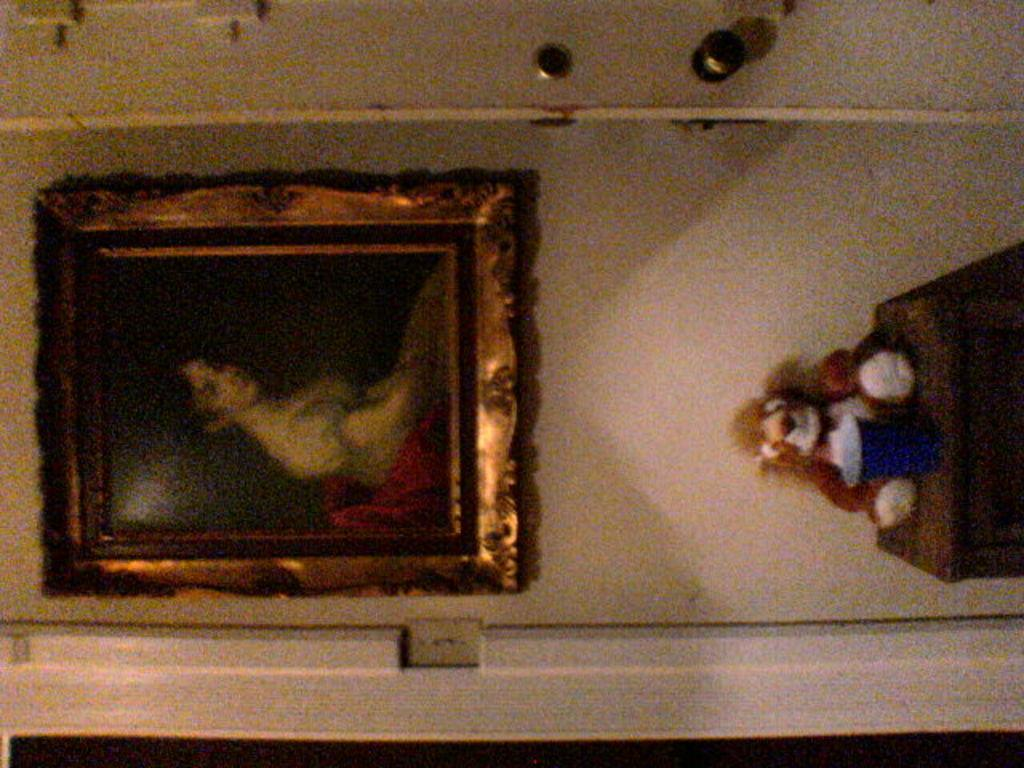What object is attached to the wall in the image? There is a photo frame in the image, and it is attached to the wall. What is located below the photo frame? There is a toy on a stool below the photo frame. What can be seen at the top of the image? There is a door at the top of the image. What year is depicted in the photo frame in the image? There is no information about the year or content of the photo in the image, so we cannot determine that. 